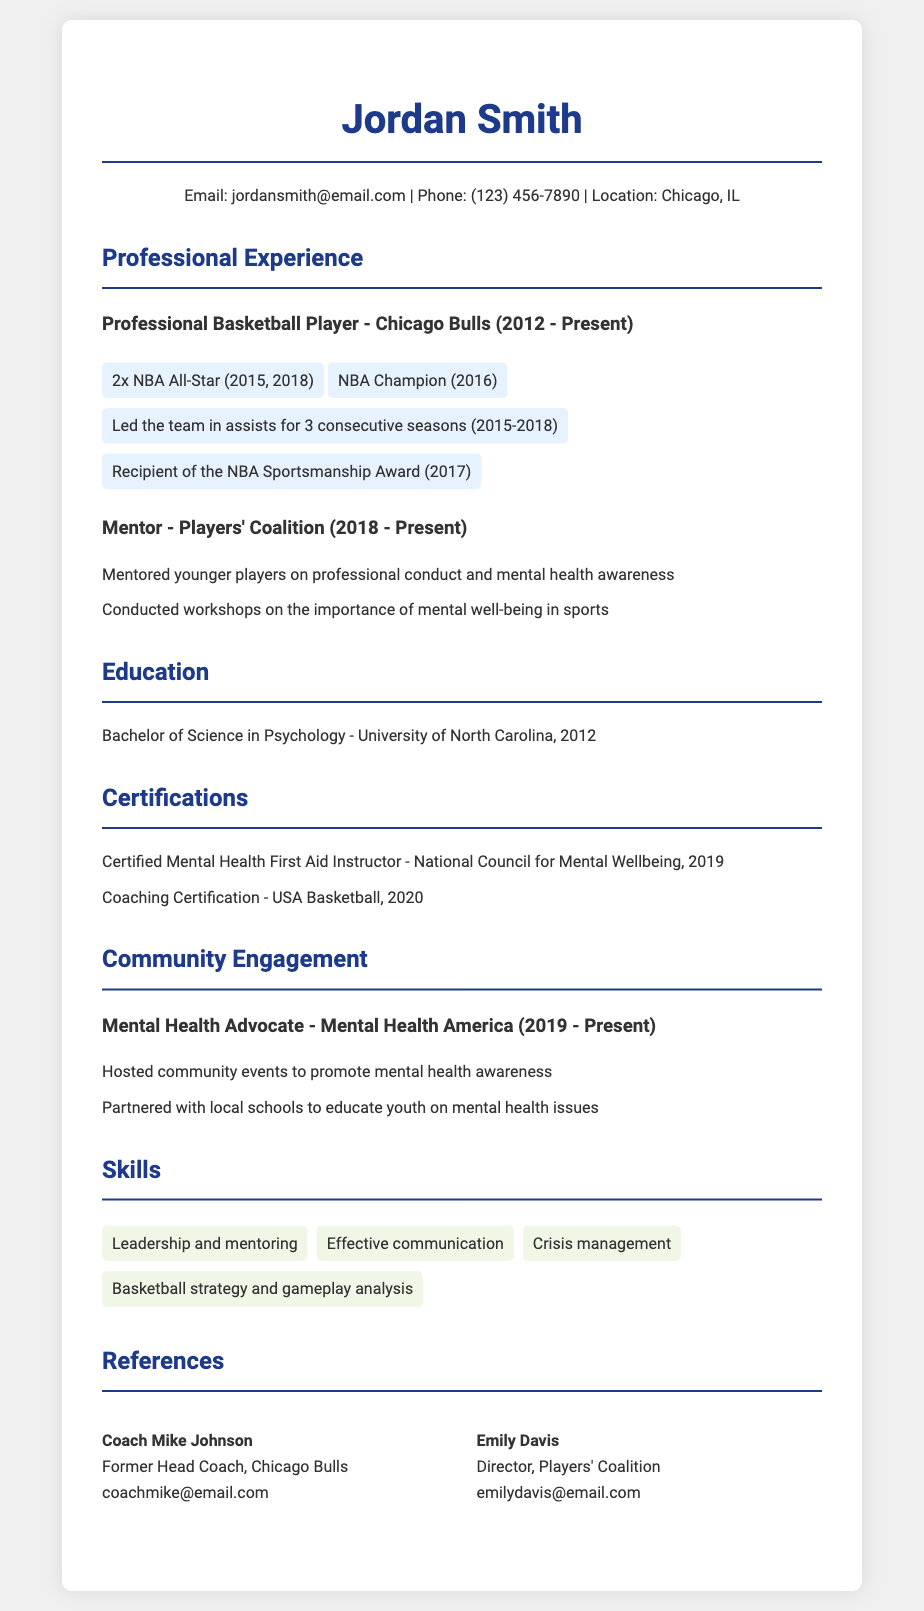What team did Jordan Smith play for? Jordan Smith played for the Chicago Bulls as stated in the document under Professional Experience.
Answer: Chicago Bulls What year did Jordan Smith win the NBA Championship? The NBA Championship was won in the year 2016, mentioned in the list of achievements.
Answer: 2016 How many times was Jordan Smith an NBA All-Star? The document indicates he was an NBA All-Star twice, specifically in 2015 and 2018.
Answer: 2 What role does Jordan Smith have with Players' Coalition? He is listed as a Mentor to younger players as detailed in the Professional Experience section.
Answer: Mentor In which year did Jordan Smith become a Certified Mental Health First Aid Instructor? The document specifies that he received this certification in 2019.
Answer: 2019 What is one of Jordan’s skills mentioned in the CV? The skills section lists several abilities, one of which is effective communication.
Answer: Effective communication What organization does Jordan Smith partner with to educate youth on mental health? The document states he partners with local schools for mental health education.
Answer: Local schools What degree did Jordan Smith earn and from which university? He earned a Bachelor of Science in Psychology from the University of North Carolina in 2012.
Answer: Bachelor of Science in Psychology - University of North Carolina What award did Jordan Smith receive in 2017? The document mentions he was the recipient of the NBA Sportsmanship Award in 2017.
Answer: NBA Sportsmanship Award 